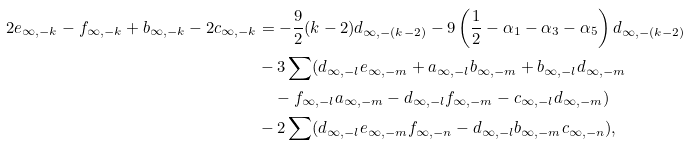Convert formula to latex. <formula><loc_0><loc_0><loc_500><loc_500>2 e _ { \infty , - k } - f _ { \infty , - k } + b _ { \infty , - k } - 2 c _ { \infty , - k } & = - \frac { 9 } { 2 } ( k - 2 ) d _ { \infty , - ( k - 2 ) } - 9 \left ( \frac { 1 } { 2 } - \alpha _ { 1 } - \alpha _ { 3 } - \alpha _ { 5 } \right ) d _ { \infty , - ( k - 2 ) } \\ & - 3 \sum ( d _ { \infty , - l } e _ { \infty , - m } + a _ { \infty , - l } b _ { \infty , - m } + b _ { \infty , - l } d _ { \infty , - m } \\ & \quad - f _ { \infty , - l } a _ { \infty , - m } - d _ { \infty , - l } f _ { \infty , - m } - c _ { \infty , - l } d _ { \infty , - m } ) \\ & - 2 \sum ( d _ { \infty , - l } e _ { \infty , - m } f _ { \infty , - n } - d _ { \infty , - l } b _ { \infty , - m } c _ { \infty , - n } ) ,</formula> 